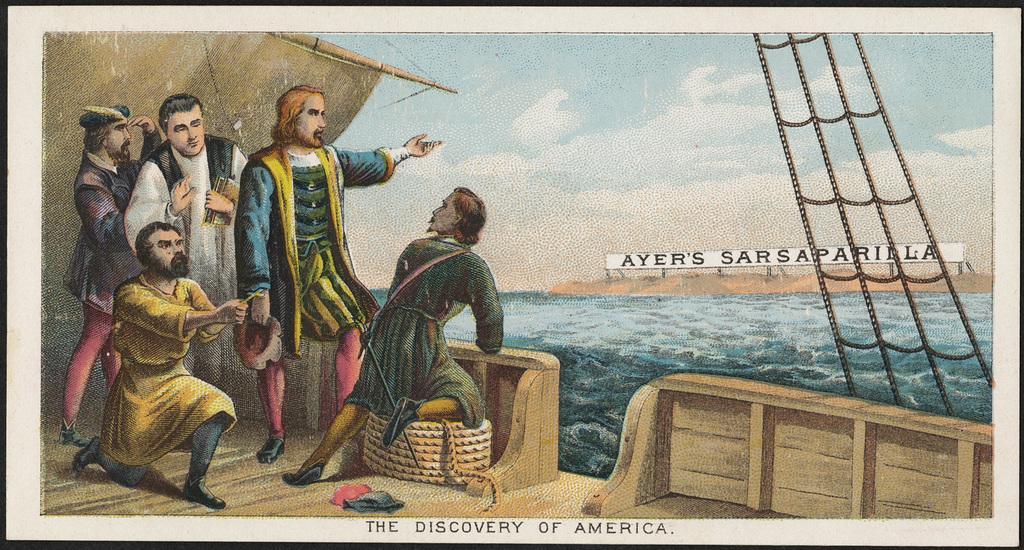Please provide a concise description of this image. This image is a painting. In this image we can see a ship and there are people in the ship. We can see ropes. In the background there is water and we can see hills. At the top there is sky. 